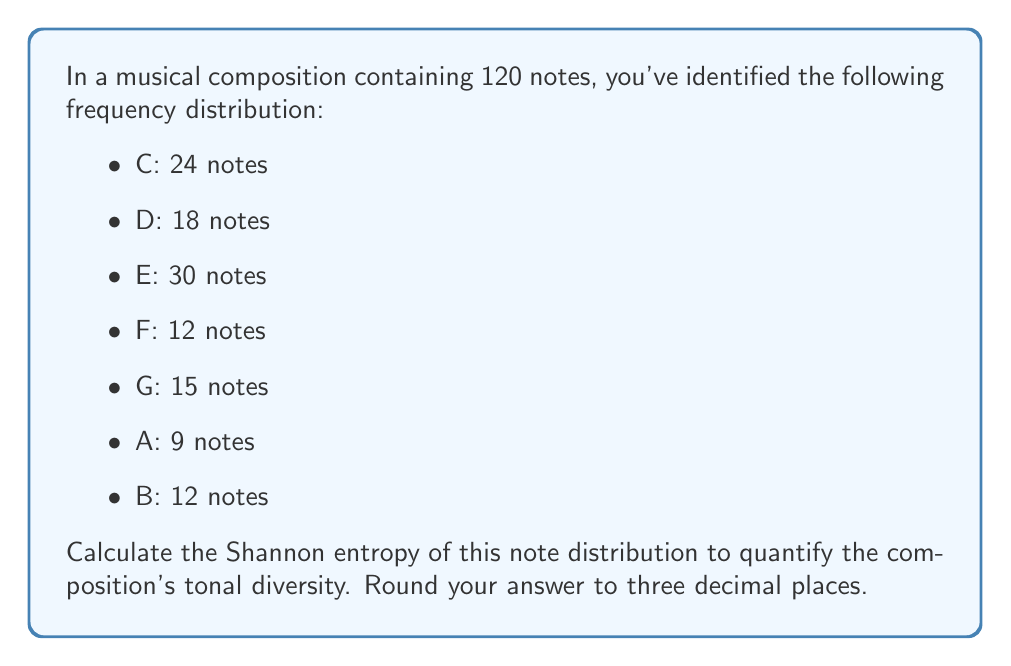Solve this math problem. To calculate the Shannon entropy of the note distribution, we'll follow these steps:

1) First, let's recall the formula for Shannon entropy:

   $$H = -\sum_{i=1}^n p_i \log_2(p_i)$$

   Where $p_i$ is the probability of each note occurring.

2) Calculate the probability of each note:

   C: $p_1 = 24/120 = 0.2$
   D: $p_2 = 18/120 = 0.15$
   E: $p_3 = 30/120 = 0.25$
   F: $p_4 = 12/120 = 0.1$
   G: $p_5 = 15/120 = 0.125$
   A: $p_6 = 9/120 = 0.075$
   B: $p_7 = 12/120 = 0.1$

3) Now, let's calculate each term of the sum:

   $-0.2 \log_2(0.2) \approx 0.464$
   $-0.15 \log_2(0.15) \approx 0.411$
   $-0.25 \log_2(0.25) \approx 0.5$
   $-0.1 \log_2(0.1) \approx 0.332$
   $-0.125 \log_2(0.125) \approx 0.375$
   $-0.075 \log_2(0.075) \approx 0.284$
   $-0.1 \log_2(0.1) \approx 0.332$

4) Sum all these terms:

   $H = 0.464 + 0.411 + 0.5 + 0.332 + 0.375 + 0.284 + 0.332 = 2.698$

5) Rounding to three decimal places:

   $H \approx 2.698$

This value represents the tonal diversity of the composition. A higher value indicates more diversity in note usage.
Answer: 2.698 